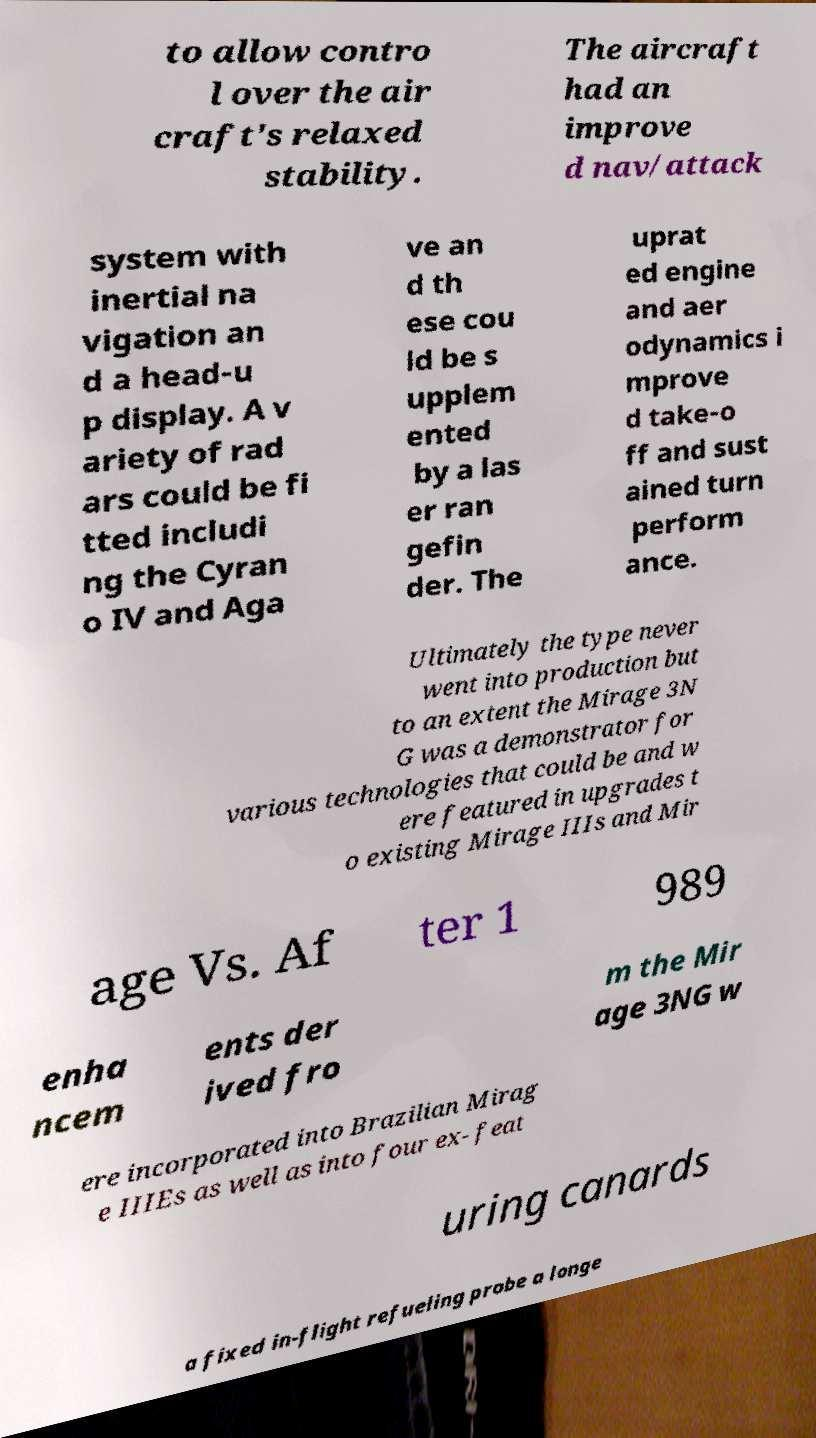Could you assist in decoding the text presented in this image and type it out clearly? to allow contro l over the air craft's relaxed stability. The aircraft had an improve d nav/attack system with inertial na vigation an d a head-u p display. A v ariety of rad ars could be fi tted includi ng the Cyran o IV and Aga ve an d th ese cou ld be s upplem ented by a las er ran gefin der. The uprat ed engine and aer odynamics i mprove d take-o ff and sust ained turn perform ance. Ultimately the type never went into production but to an extent the Mirage 3N G was a demonstrator for various technologies that could be and w ere featured in upgrades t o existing Mirage IIIs and Mir age Vs. Af ter 1 989 enha ncem ents der ived fro m the Mir age 3NG w ere incorporated into Brazilian Mirag e IIIEs as well as into four ex- feat uring canards a fixed in-flight refueling probe a longe 